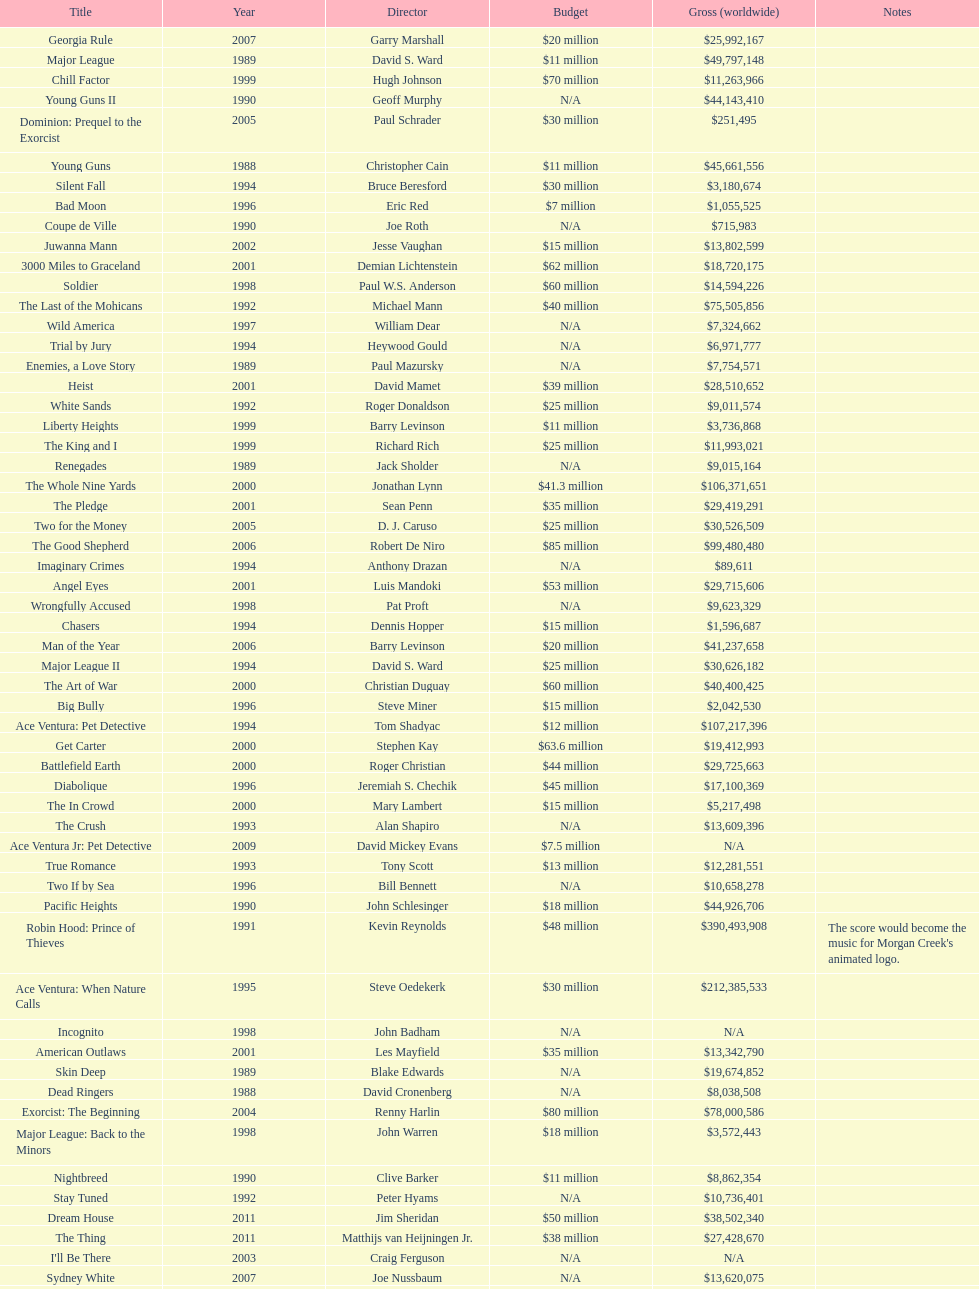How many films did morgan creek make in 2006? 2. 